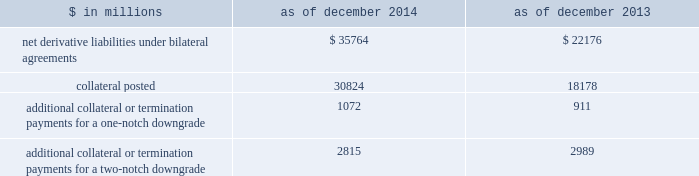Notes to consolidated financial statements derivatives with credit-related contingent features certain of the firm 2019s derivatives have been transacted under bilateral agreements with counterparties who may require the firm to post collateral or terminate the transactions based on changes in the firm 2019s credit ratings .
The firm assesses the impact of these bilateral agreements by determining the collateral or termination payments that would occur assuming a downgrade by all rating agencies .
A downgrade by any one rating agency , depending on the agency 2019s relative ratings of the firm at the time of the downgrade , may have an impact which is comparable to the impact of a downgrade by all rating agencies .
The table below presents the aggregate fair value of net derivative liabilities under such agreements ( excluding application of collateral posted to reduce these liabilities ) , the related aggregate fair value of the assets posted as collateral , and the additional collateral or termination payments that could have been called at the reporting date by counterparties in the event of a one-notch and two-notch downgrade in the firm 2019s credit ratings. .
Additional collateral or termination payments for a one-notch downgrade 1072 911 additional collateral or termination payments for a two-notch downgrade 2815 2989 credit derivatives the firm enters into a broad array of credit derivatives in locations around the world to facilitate client transactions and to manage the credit risk associated with market- making and investing and lending activities .
Credit derivatives are actively managed based on the firm 2019s net risk position .
Credit derivatives are individually negotiated contracts and can have various settlement and payment conventions .
Credit events include failure to pay , bankruptcy , acceleration of indebtedness , restructuring , repudiation and dissolution of the reference entity .
Credit default swaps .
Single-name credit default swaps protect the buyer against the loss of principal on one or more bonds , loans or mortgages ( reference obligations ) in the event the issuer ( reference entity ) of the reference obligations suffers a credit event .
The buyer of protection pays an initial or periodic premium to the seller and receives protection for the period of the contract .
If there is no credit event , as defined in the contract , the seller of protection makes no payments to the buyer of protection .
However , if a credit event occurs , the seller of protection is required to make a payment to the buyer of protection , which is calculated in accordance with the terms of the contract .
Credit indices , baskets and tranches .
Credit derivatives may reference a basket of single-name credit default swaps or a broad-based index .
If a credit event occurs in one of the underlying reference obligations , the protection seller pays the protection buyer .
The payment is typically a pro-rata portion of the transaction 2019s total notional amount based on the underlying defaulted reference obligation .
In certain transactions , the credit risk of a basket or index is separated into various portions ( tranches ) , each having different levels of subordination .
The most junior tranches cover initial defaults and once losses exceed the notional amount of these junior tranches , any excess loss is covered by the next most senior tranche in the capital structure .
Total return swaps .
A total return swap transfers the risks relating to economic performance of a reference obligation from the protection buyer to the protection seller .
Typically , the protection buyer receives from the protection seller a floating rate of interest and protection against any reduction in fair value of the reference obligation , and in return the protection seller receives the cash flows associated with the reference obligation , plus any increase in the fair value of the reference obligation .
132 goldman sachs 2014 annual report .
In millions for 2014 and 2013 , what was total amount of net derivative liabilities under bilateral agreements?\\n? 
Computations: table_sum(net derivative liabilities under bilateral agreements, none)
Answer: 57940.0. 